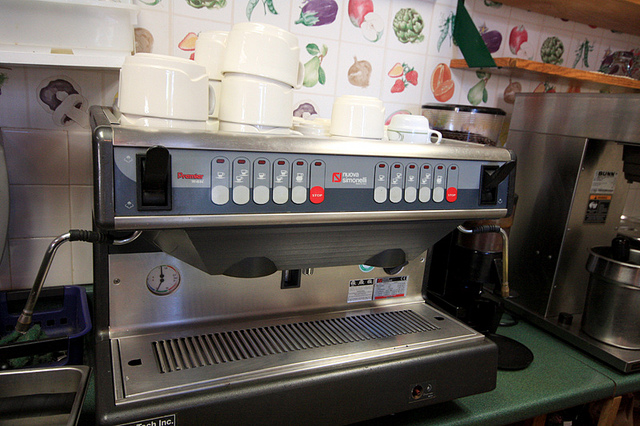What are the cups on top of the machine for? The cups on top of the espresso machine are being warmed. Warming cups before serving coffee helps maintain the beverage's temperature and enhances the overall drinking experience. 